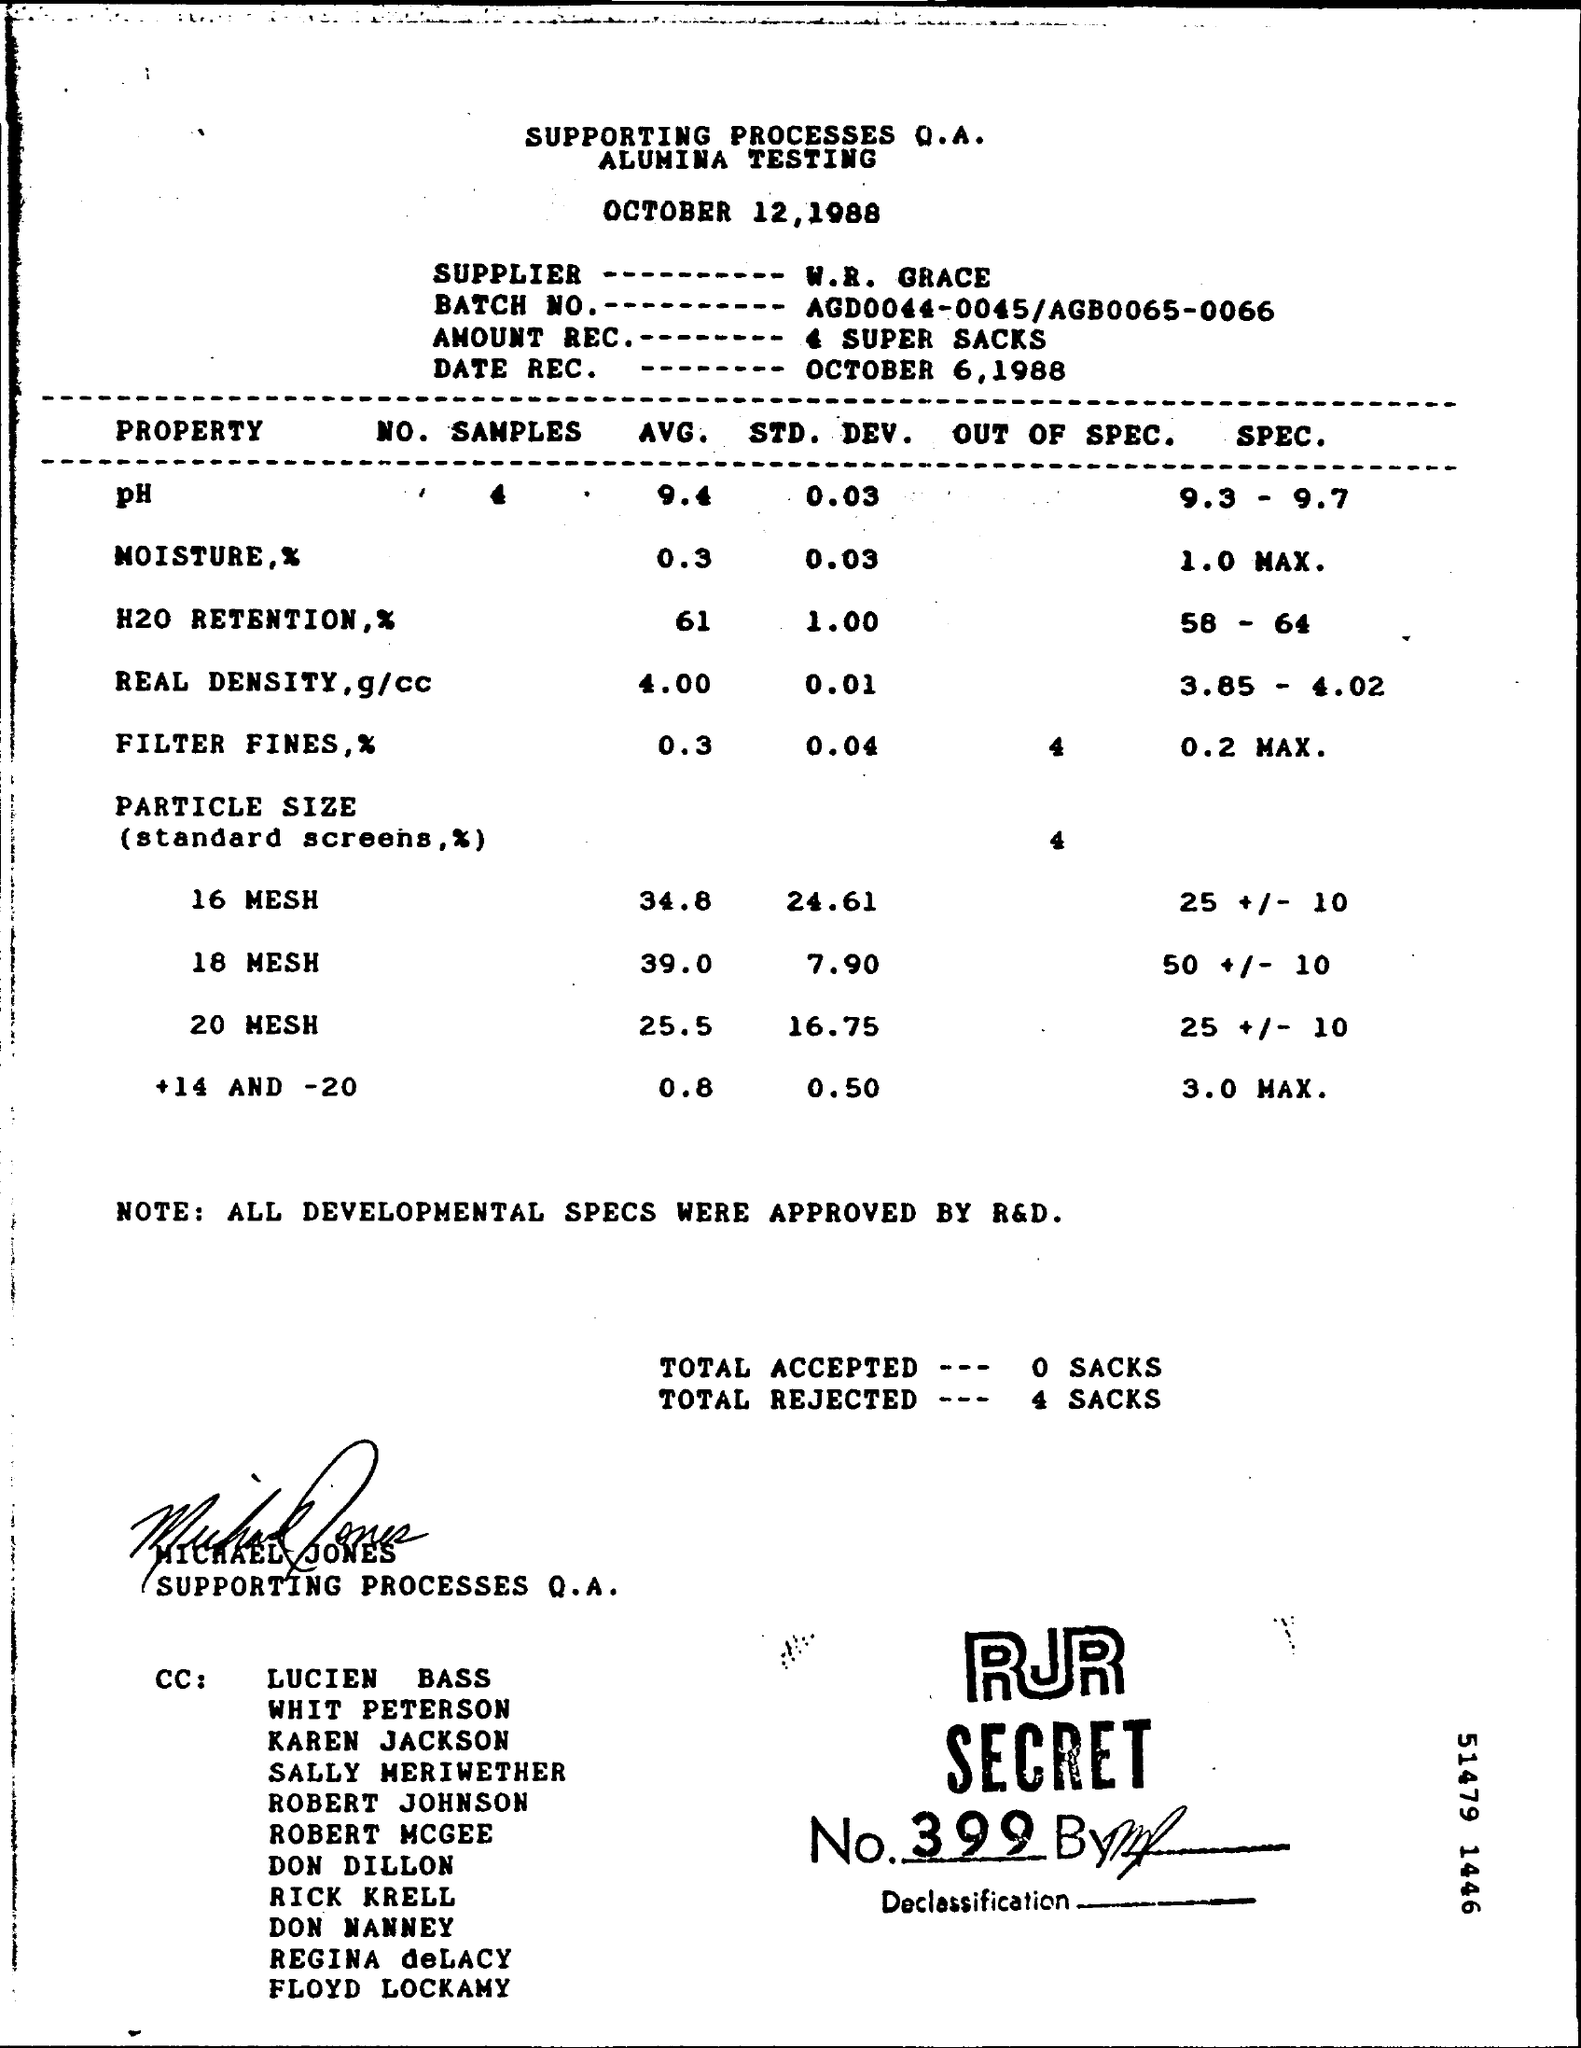Indicate a few pertinent items in this graphic. The average value of the 16 mesh mentioned in the table is 34.8. The RJR secret number is 399... The average moisture percentage is approximately 0.3. All development specifications were approved by R&D. 